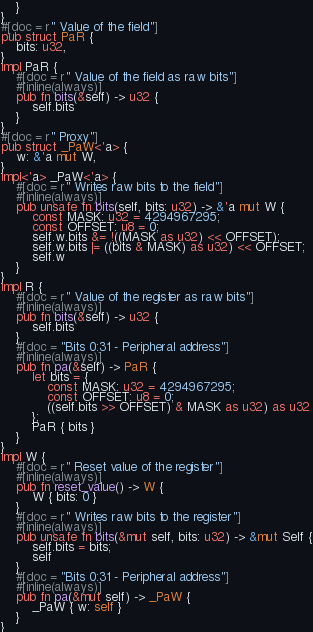Convert code to text. <code><loc_0><loc_0><loc_500><loc_500><_Rust_>    }
}
#[doc = r" Value of the field"]
pub struct PaR {
    bits: u32,
}
impl PaR {
    #[doc = r" Value of the field as raw bits"]
    #[inline(always)]
    pub fn bits(&self) -> u32 {
        self.bits
    }
}
#[doc = r" Proxy"]
pub struct _PaW<'a> {
    w: &'a mut W,
}
impl<'a> _PaW<'a> {
    #[doc = r" Writes raw bits to the field"]
    #[inline(always)]
    pub unsafe fn bits(self, bits: u32) -> &'a mut W {
        const MASK: u32 = 4294967295;
        const OFFSET: u8 = 0;
        self.w.bits &= !((MASK as u32) << OFFSET);
        self.w.bits |= ((bits & MASK) as u32) << OFFSET;
        self.w
    }
}
impl R {
    #[doc = r" Value of the register as raw bits"]
    #[inline(always)]
    pub fn bits(&self) -> u32 {
        self.bits
    }
    #[doc = "Bits 0:31 - Peripheral address"]
    #[inline(always)]
    pub fn pa(&self) -> PaR {
        let bits = {
            const MASK: u32 = 4294967295;
            const OFFSET: u8 = 0;
            ((self.bits >> OFFSET) & MASK as u32) as u32
        };
        PaR { bits }
    }
}
impl W {
    #[doc = r" Reset value of the register"]
    #[inline(always)]
    pub fn reset_value() -> W {
        W { bits: 0 }
    }
    #[doc = r" Writes raw bits to the register"]
    #[inline(always)]
    pub unsafe fn bits(&mut self, bits: u32) -> &mut Self {
        self.bits = bits;
        self
    }
    #[doc = "Bits 0:31 - Peripheral address"]
    #[inline(always)]
    pub fn pa(&mut self) -> _PaW {
        _PaW { w: self }
    }
}
</code> 